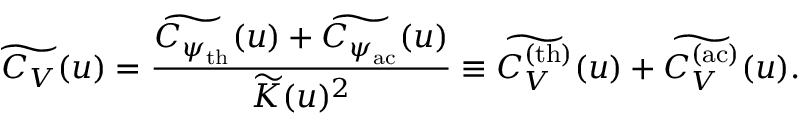<formula> <loc_0><loc_0><loc_500><loc_500>\widetilde { C _ { V } } ( u ) = \frac { \widetilde { C _ { \psi _ { t h } } } ( u ) + \widetilde { C _ { \psi _ { a c } } } ( u ) } { \widetilde { K } ( u ) ^ { 2 } } \equiv \widetilde { C _ { V } ^ { ( t h ) } } ( u ) + \widetilde { C _ { V } ^ { ( a c ) } } ( u ) .</formula> 